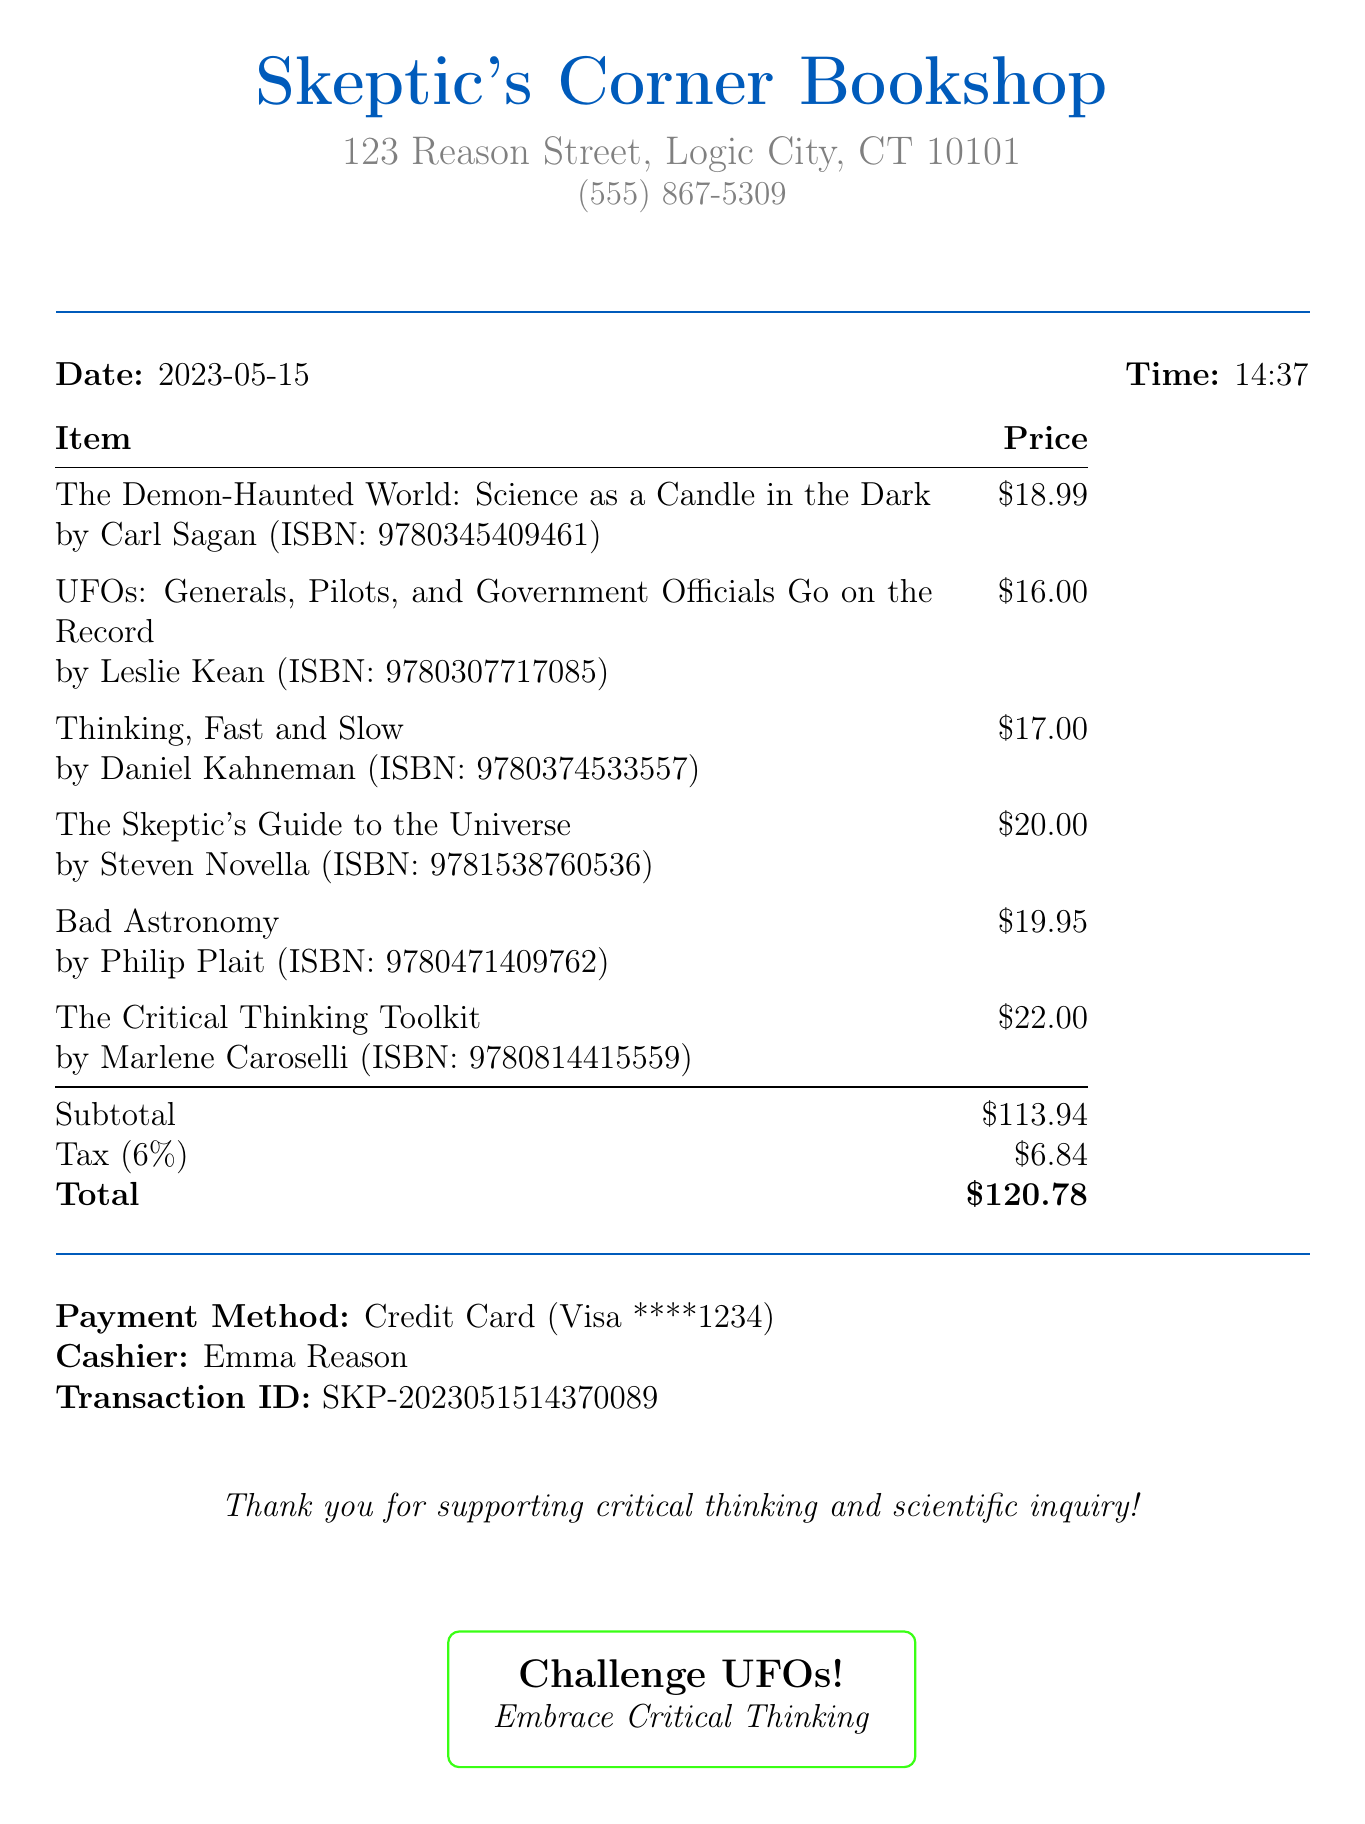What is the total amount paid? The total amount paid is listed at the bottom of the receipt, summarizing the subtotal plus tax.
Answer: $120.78 Who is the author of "Bad Astronomy"? The author is named next to the title in the receipt.
Answer: Philip Plait What is the ISBN of "Thinking, Fast and Slow"? The ISBN is provided in parentheses next to the title and author on the receipt.
Answer: 9780374533557 What is the subtotal amount before tax? The subtotal amount is presented in the receipt before the tax is added.
Answer: $113.94 What payment method was used? The payment method is specified in the transaction details section of the receipt.
Answer: Credit Card How much tax was charged? The tax amount is detailed on the receipt, calculated at the specified tax rate.
Answer: $6.84 What is the title of the book by Carl Sagan? The title is clearly listed at the beginning of the itemized list on the receipt.
Answer: The Demon-Haunted World: Science as a Candle in the Dark What was the date of the transaction? The date is noted prominently in the header of the receipt.
Answer: 2023-05-15 Who was the cashier for this transaction? The cashier's name is provided in the transaction details toward the end of the receipt.
Answer: Emma Reason 